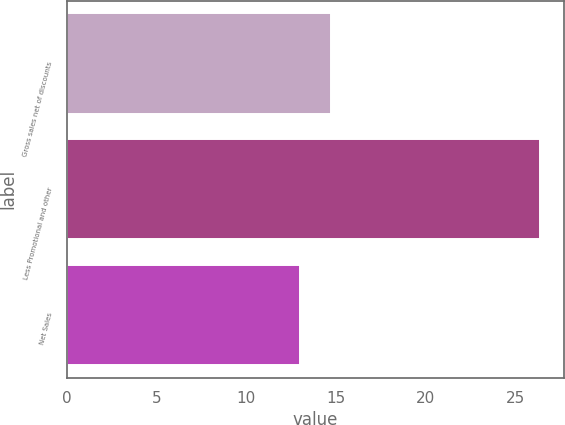Convert chart to OTSL. <chart><loc_0><loc_0><loc_500><loc_500><bar_chart><fcel>Gross sales net of discounts<fcel>Less Promotional and other<fcel>Net Sales<nl><fcel>14.7<fcel>26.4<fcel>13<nl></chart> 